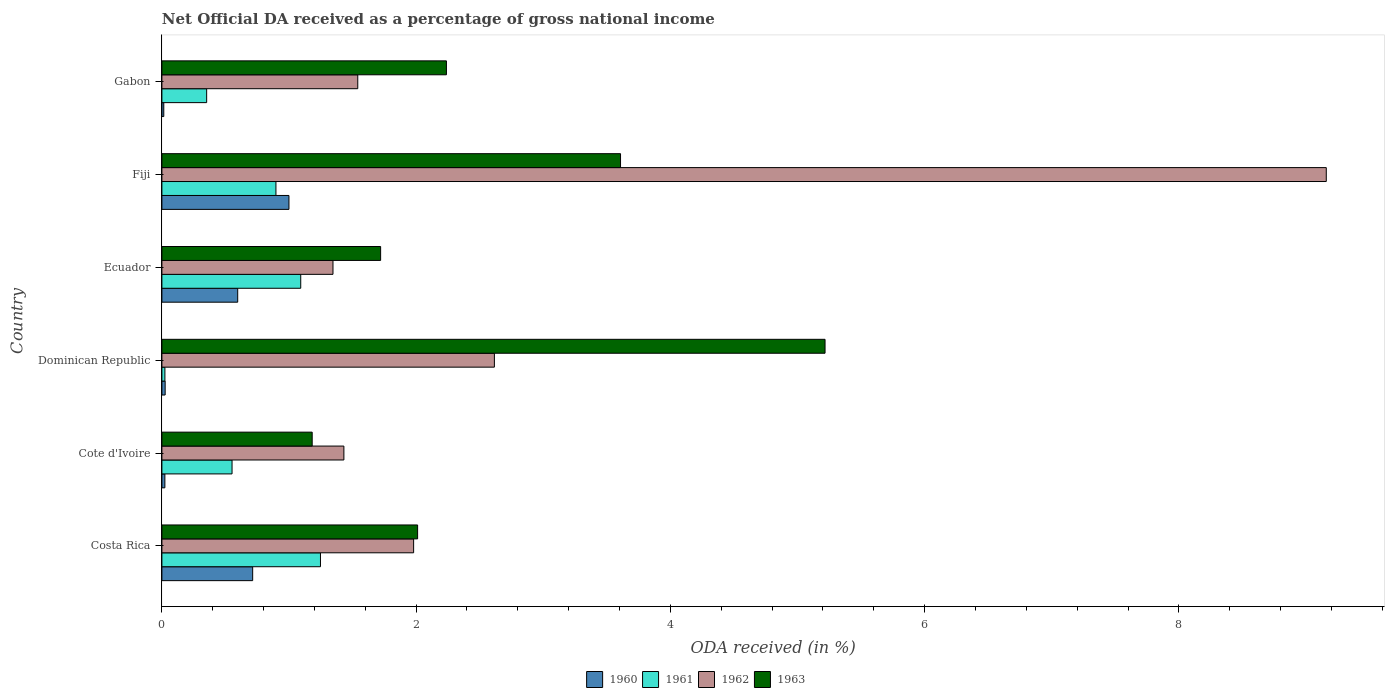How many different coloured bars are there?
Provide a succinct answer. 4. How many bars are there on the 4th tick from the top?
Make the answer very short. 4. How many bars are there on the 4th tick from the bottom?
Keep it short and to the point. 4. What is the label of the 4th group of bars from the top?
Make the answer very short. Dominican Republic. In how many cases, is the number of bars for a given country not equal to the number of legend labels?
Provide a short and direct response. 0. What is the net official DA received in 1961 in Cote d'Ivoire?
Keep it short and to the point. 0.55. Across all countries, what is the maximum net official DA received in 1962?
Keep it short and to the point. 9.16. Across all countries, what is the minimum net official DA received in 1961?
Offer a terse response. 0.02. In which country was the net official DA received in 1960 maximum?
Offer a terse response. Fiji. In which country was the net official DA received in 1962 minimum?
Ensure brevity in your answer.  Ecuador. What is the total net official DA received in 1960 in the graph?
Make the answer very short. 2.37. What is the difference between the net official DA received in 1963 in Costa Rica and that in Dominican Republic?
Your answer should be compact. -3.21. What is the difference between the net official DA received in 1962 in Fiji and the net official DA received in 1963 in Gabon?
Offer a very short reply. 6.92. What is the average net official DA received in 1962 per country?
Ensure brevity in your answer.  3.01. What is the difference between the net official DA received in 1960 and net official DA received in 1963 in Ecuador?
Provide a short and direct response. -1.12. What is the ratio of the net official DA received in 1960 in Cote d'Ivoire to that in Ecuador?
Your answer should be compact. 0.04. What is the difference between the highest and the second highest net official DA received in 1960?
Offer a terse response. 0.29. What is the difference between the highest and the lowest net official DA received in 1961?
Offer a very short reply. 1.22. Is it the case that in every country, the sum of the net official DA received in 1963 and net official DA received in 1960 is greater than the sum of net official DA received in 1961 and net official DA received in 1962?
Provide a short and direct response. No. How many bars are there?
Your answer should be compact. 24. How many countries are there in the graph?
Your answer should be very brief. 6. What is the difference between two consecutive major ticks on the X-axis?
Provide a short and direct response. 2. Are the values on the major ticks of X-axis written in scientific E-notation?
Your answer should be very brief. No. Does the graph contain any zero values?
Give a very brief answer. No. How many legend labels are there?
Provide a succinct answer. 4. What is the title of the graph?
Give a very brief answer. Net Official DA received as a percentage of gross national income. Does "1981" appear as one of the legend labels in the graph?
Provide a succinct answer. No. What is the label or title of the X-axis?
Offer a very short reply. ODA received (in %). What is the label or title of the Y-axis?
Your answer should be very brief. Country. What is the ODA received (in %) of 1960 in Costa Rica?
Your response must be concise. 0.71. What is the ODA received (in %) in 1961 in Costa Rica?
Your response must be concise. 1.25. What is the ODA received (in %) of 1962 in Costa Rica?
Your answer should be compact. 1.98. What is the ODA received (in %) of 1963 in Costa Rica?
Offer a terse response. 2.01. What is the ODA received (in %) in 1960 in Cote d'Ivoire?
Your answer should be compact. 0.02. What is the ODA received (in %) of 1961 in Cote d'Ivoire?
Offer a terse response. 0.55. What is the ODA received (in %) in 1962 in Cote d'Ivoire?
Give a very brief answer. 1.43. What is the ODA received (in %) of 1963 in Cote d'Ivoire?
Your answer should be very brief. 1.18. What is the ODA received (in %) in 1960 in Dominican Republic?
Offer a very short reply. 0.03. What is the ODA received (in %) in 1961 in Dominican Republic?
Your response must be concise. 0.02. What is the ODA received (in %) of 1962 in Dominican Republic?
Give a very brief answer. 2.62. What is the ODA received (in %) in 1963 in Dominican Republic?
Make the answer very short. 5.22. What is the ODA received (in %) of 1960 in Ecuador?
Provide a short and direct response. 0.6. What is the ODA received (in %) of 1961 in Ecuador?
Keep it short and to the point. 1.09. What is the ODA received (in %) in 1962 in Ecuador?
Your response must be concise. 1.35. What is the ODA received (in %) of 1963 in Ecuador?
Your answer should be very brief. 1.72. What is the ODA received (in %) of 1960 in Fiji?
Offer a terse response. 1. What is the ODA received (in %) of 1961 in Fiji?
Provide a succinct answer. 0.9. What is the ODA received (in %) of 1962 in Fiji?
Your answer should be very brief. 9.16. What is the ODA received (in %) of 1963 in Fiji?
Your response must be concise. 3.61. What is the ODA received (in %) of 1960 in Gabon?
Offer a terse response. 0.01. What is the ODA received (in %) of 1961 in Gabon?
Your answer should be compact. 0.35. What is the ODA received (in %) in 1962 in Gabon?
Offer a terse response. 1.54. What is the ODA received (in %) of 1963 in Gabon?
Offer a terse response. 2.24. Across all countries, what is the maximum ODA received (in %) of 1960?
Your answer should be compact. 1. Across all countries, what is the maximum ODA received (in %) of 1961?
Ensure brevity in your answer.  1.25. Across all countries, what is the maximum ODA received (in %) in 1962?
Provide a short and direct response. 9.16. Across all countries, what is the maximum ODA received (in %) in 1963?
Provide a succinct answer. 5.22. Across all countries, what is the minimum ODA received (in %) of 1960?
Keep it short and to the point. 0.01. Across all countries, what is the minimum ODA received (in %) of 1961?
Provide a succinct answer. 0.02. Across all countries, what is the minimum ODA received (in %) of 1962?
Provide a short and direct response. 1.35. Across all countries, what is the minimum ODA received (in %) in 1963?
Your answer should be compact. 1.18. What is the total ODA received (in %) in 1960 in the graph?
Offer a terse response. 2.37. What is the total ODA received (in %) of 1961 in the graph?
Keep it short and to the point. 4.16. What is the total ODA received (in %) in 1962 in the graph?
Offer a terse response. 18.07. What is the total ODA received (in %) of 1963 in the graph?
Provide a succinct answer. 15.98. What is the difference between the ODA received (in %) in 1960 in Costa Rica and that in Cote d'Ivoire?
Your answer should be compact. 0.69. What is the difference between the ODA received (in %) of 1961 in Costa Rica and that in Cote d'Ivoire?
Provide a succinct answer. 0.7. What is the difference between the ODA received (in %) in 1962 in Costa Rica and that in Cote d'Ivoire?
Ensure brevity in your answer.  0.55. What is the difference between the ODA received (in %) of 1963 in Costa Rica and that in Cote d'Ivoire?
Your answer should be compact. 0.83. What is the difference between the ODA received (in %) of 1960 in Costa Rica and that in Dominican Republic?
Ensure brevity in your answer.  0.69. What is the difference between the ODA received (in %) of 1961 in Costa Rica and that in Dominican Republic?
Your answer should be compact. 1.22. What is the difference between the ODA received (in %) in 1962 in Costa Rica and that in Dominican Republic?
Give a very brief answer. -0.64. What is the difference between the ODA received (in %) of 1963 in Costa Rica and that in Dominican Republic?
Give a very brief answer. -3.21. What is the difference between the ODA received (in %) in 1960 in Costa Rica and that in Ecuador?
Keep it short and to the point. 0.12. What is the difference between the ODA received (in %) of 1961 in Costa Rica and that in Ecuador?
Keep it short and to the point. 0.16. What is the difference between the ODA received (in %) of 1962 in Costa Rica and that in Ecuador?
Provide a short and direct response. 0.63. What is the difference between the ODA received (in %) in 1963 in Costa Rica and that in Ecuador?
Your answer should be compact. 0.29. What is the difference between the ODA received (in %) of 1960 in Costa Rica and that in Fiji?
Your response must be concise. -0.29. What is the difference between the ODA received (in %) in 1961 in Costa Rica and that in Fiji?
Keep it short and to the point. 0.35. What is the difference between the ODA received (in %) in 1962 in Costa Rica and that in Fiji?
Your answer should be compact. -7.18. What is the difference between the ODA received (in %) of 1963 in Costa Rica and that in Fiji?
Offer a very short reply. -1.6. What is the difference between the ODA received (in %) in 1960 in Costa Rica and that in Gabon?
Offer a terse response. 0.7. What is the difference between the ODA received (in %) in 1961 in Costa Rica and that in Gabon?
Provide a short and direct response. 0.9. What is the difference between the ODA received (in %) of 1962 in Costa Rica and that in Gabon?
Ensure brevity in your answer.  0.44. What is the difference between the ODA received (in %) in 1963 in Costa Rica and that in Gabon?
Offer a very short reply. -0.23. What is the difference between the ODA received (in %) of 1960 in Cote d'Ivoire and that in Dominican Republic?
Give a very brief answer. -0. What is the difference between the ODA received (in %) of 1961 in Cote d'Ivoire and that in Dominican Republic?
Give a very brief answer. 0.53. What is the difference between the ODA received (in %) in 1962 in Cote d'Ivoire and that in Dominican Republic?
Make the answer very short. -1.18. What is the difference between the ODA received (in %) in 1963 in Cote d'Ivoire and that in Dominican Republic?
Make the answer very short. -4.03. What is the difference between the ODA received (in %) of 1960 in Cote d'Ivoire and that in Ecuador?
Offer a very short reply. -0.57. What is the difference between the ODA received (in %) of 1961 in Cote d'Ivoire and that in Ecuador?
Your answer should be very brief. -0.54. What is the difference between the ODA received (in %) in 1962 in Cote d'Ivoire and that in Ecuador?
Your response must be concise. 0.09. What is the difference between the ODA received (in %) of 1963 in Cote d'Ivoire and that in Ecuador?
Ensure brevity in your answer.  -0.54. What is the difference between the ODA received (in %) in 1960 in Cote d'Ivoire and that in Fiji?
Offer a terse response. -0.98. What is the difference between the ODA received (in %) of 1961 in Cote d'Ivoire and that in Fiji?
Ensure brevity in your answer.  -0.35. What is the difference between the ODA received (in %) in 1962 in Cote d'Ivoire and that in Fiji?
Offer a very short reply. -7.73. What is the difference between the ODA received (in %) in 1963 in Cote d'Ivoire and that in Fiji?
Offer a very short reply. -2.43. What is the difference between the ODA received (in %) in 1960 in Cote d'Ivoire and that in Gabon?
Offer a very short reply. 0.01. What is the difference between the ODA received (in %) of 1961 in Cote d'Ivoire and that in Gabon?
Provide a short and direct response. 0.2. What is the difference between the ODA received (in %) in 1962 in Cote d'Ivoire and that in Gabon?
Provide a short and direct response. -0.11. What is the difference between the ODA received (in %) in 1963 in Cote d'Ivoire and that in Gabon?
Ensure brevity in your answer.  -1.06. What is the difference between the ODA received (in %) in 1960 in Dominican Republic and that in Ecuador?
Your response must be concise. -0.57. What is the difference between the ODA received (in %) in 1961 in Dominican Republic and that in Ecuador?
Ensure brevity in your answer.  -1.07. What is the difference between the ODA received (in %) in 1962 in Dominican Republic and that in Ecuador?
Offer a very short reply. 1.27. What is the difference between the ODA received (in %) in 1963 in Dominican Republic and that in Ecuador?
Provide a short and direct response. 3.5. What is the difference between the ODA received (in %) in 1960 in Dominican Republic and that in Fiji?
Provide a succinct answer. -0.97. What is the difference between the ODA received (in %) in 1961 in Dominican Republic and that in Fiji?
Give a very brief answer. -0.87. What is the difference between the ODA received (in %) in 1962 in Dominican Republic and that in Fiji?
Your answer should be compact. -6.54. What is the difference between the ODA received (in %) in 1963 in Dominican Republic and that in Fiji?
Your answer should be compact. 1.61. What is the difference between the ODA received (in %) in 1960 in Dominican Republic and that in Gabon?
Provide a succinct answer. 0.01. What is the difference between the ODA received (in %) of 1961 in Dominican Republic and that in Gabon?
Offer a terse response. -0.33. What is the difference between the ODA received (in %) in 1962 in Dominican Republic and that in Gabon?
Your answer should be compact. 1.07. What is the difference between the ODA received (in %) in 1963 in Dominican Republic and that in Gabon?
Provide a succinct answer. 2.98. What is the difference between the ODA received (in %) of 1960 in Ecuador and that in Fiji?
Offer a very short reply. -0.4. What is the difference between the ODA received (in %) of 1961 in Ecuador and that in Fiji?
Make the answer very short. 0.2. What is the difference between the ODA received (in %) of 1962 in Ecuador and that in Fiji?
Keep it short and to the point. -7.81. What is the difference between the ODA received (in %) of 1963 in Ecuador and that in Fiji?
Provide a short and direct response. -1.89. What is the difference between the ODA received (in %) of 1960 in Ecuador and that in Gabon?
Offer a very short reply. 0.58. What is the difference between the ODA received (in %) in 1961 in Ecuador and that in Gabon?
Keep it short and to the point. 0.74. What is the difference between the ODA received (in %) of 1962 in Ecuador and that in Gabon?
Your answer should be very brief. -0.2. What is the difference between the ODA received (in %) of 1963 in Ecuador and that in Gabon?
Your answer should be very brief. -0.52. What is the difference between the ODA received (in %) in 1960 in Fiji and that in Gabon?
Your answer should be very brief. 0.98. What is the difference between the ODA received (in %) of 1961 in Fiji and that in Gabon?
Offer a terse response. 0.55. What is the difference between the ODA received (in %) in 1962 in Fiji and that in Gabon?
Your answer should be compact. 7.62. What is the difference between the ODA received (in %) of 1963 in Fiji and that in Gabon?
Offer a very short reply. 1.37. What is the difference between the ODA received (in %) of 1960 in Costa Rica and the ODA received (in %) of 1961 in Cote d'Ivoire?
Offer a very short reply. 0.16. What is the difference between the ODA received (in %) in 1960 in Costa Rica and the ODA received (in %) in 1962 in Cote d'Ivoire?
Offer a terse response. -0.72. What is the difference between the ODA received (in %) of 1960 in Costa Rica and the ODA received (in %) of 1963 in Cote d'Ivoire?
Give a very brief answer. -0.47. What is the difference between the ODA received (in %) of 1961 in Costa Rica and the ODA received (in %) of 1962 in Cote d'Ivoire?
Your answer should be compact. -0.18. What is the difference between the ODA received (in %) in 1961 in Costa Rica and the ODA received (in %) in 1963 in Cote d'Ivoire?
Your answer should be compact. 0.07. What is the difference between the ODA received (in %) in 1962 in Costa Rica and the ODA received (in %) in 1963 in Cote d'Ivoire?
Offer a very short reply. 0.8. What is the difference between the ODA received (in %) in 1960 in Costa Rica and the ODA received (in %) in 1961 in Dominican Republic?
Ensure brevity in your answer.  0.69. What is the difference between the ODA received (in %) in 1960 in Costa Rica and the ODA received (in %) in 1962 in Dominican Republic?
Your answer should be very brief. -1.9. What is the difference between the ODA received (in %) of 1960 in Costa Rica and the ODA received (in %) of 1963 in Dominican Republic?
Provide a succinct answer. -4.5. What is the difference between the ODA received (in %) of 1961 in Costa Rica and the ODA received (in %) of 1962 in Dominican Republic?
Your response must be concise. -1.37. What is the difference between the ODA received (in %) in 1961 in Costa Rica and the ODA received (in %) in 1963 in Dominican Republic?
Your answer should be compact. -3.97. What is the difference between the ODA received (in %) in 1962 in Costa Rica and the ODA received (in %) in 1963 in Dominican Republic?
Your response must be concise. -3.24. What is the difference between the ODA received (in %) in 1960 in Costa Rica and the ODA received (in %) in 1961 in Ecuador?
Give a very brief answer. -0.38. What is the difference between the ODA received (in %) of 1960 in Costa Rica and the ODA received (in %) of 1962 in Ecuador?
Offer a very short reply. -0.63. What is the difference between the ODA received (in %) in 1960 in Costa Rica and the ODA received (in %) in 1963 in Ecuador?
Your response must be concise. -1.01. What is the difference between the ODA received (in %) of 1961 in Costa Rica and the ODA received (in %) of 1962 in Ecuador?
Give a very brief answer. -0.1. What is the difference between the ODA received (in %) in 1961 in Costa Rica and the ODA received (in %) in 1963 in Ecuador?
Your answer should be compact. -0.47. What is the difference between the ODA received (in %) of 1962 in Costa Rica and the ODA received (in %) of 1963 in Ecuador?
Provide a succinct answer. 0.26. What is the difference between the ODA received (in %) in 1960 in Costa Rica and the ODA received (in %) in 1961 in Fiji?
Provide a short and direct response. -0.18. What is the difference between the ODA received (in %) in 1960 in Costa Rica and the ODA received (in %) in 1962 in Fiji?
Your response must be concise. -8.45. What is the difference between the ODA received (in %) in 1960 in Costa Rica and the ODA received (in %) in 1963 in Fiji?
Make the answer very short. -2.89. What is the difference between the ODA received (in %) in 1961 in Costa Rica and the ODA received (in %) in 1962 in Fiji?
Provide a succinct answer. -7.91. What is the difference between the ODA received (in %) of 1961 in Costa Rica and the ODA received (in %) of 1963 in Fiji?
Keep it short and to the point. -2.36. What is the difference between the ODA received (in %) of 1962 in Costa Rica and the ODA received (in %) of 1963 in Fiji?
Offer a very short reply. -1.63. What is the difference between the ODA received (in %) in 1960 in Costa Rica and the ODA received (in %) in 1961 in Gabon?
Ensure brevity in your answer.  0.36. What is the difference between the ODA received (in %) of 1960 in Costa Rica and the ODA received (in %) of 1962 in Gabon?
Ensure brevity in your answer.  -0.83. What is the difference between the ODA received (in %) of 1960 in Costa Rica and the ODA received (in %) of 1963 in Gabon?
Provide a succinct answer. -1.52. What is the difference between the ODA received (in %) of 1961 in Costa Rica and the ODA received (in %) of 1962 in Gabon?
Keep it short and to the point. -0.29. What is the difference between the ODA received (in %) of 1961 in Costa Rica and the ODA received (in %) of 1963 in Gabon?
Provide a short and direct response. -0.99. What is the difference between the ODA received (in %) of 1962 in Costa Rica and the ODA received (in %) of 1963 in Gabon?
Your answer should be compact. -0.26. What is the difference between the ODA received (in %) in 1960 in Cote d'Ivoire and the ODA received (in %) in 1961 in Dominican Republic?
Your response must be concise. -0. What is the difference between the ODA received (in %) in 1960 in Cote d'Ivoire and the ODA received (in %) in 1962 in Dominican Republic?
Offer a terse response. -2.59. What is the difference between the ODA received (in %) of 1960 in Cote d'Ivoire and the ODA received (in %) of 1963 in Dominican Republic?
Offer a terse response. -5.19. What is the difference between the ODA received (in %) of 1961 in Cote d'Ivoire and the ODA received (in %) of 1962 in Dominican Republic?
Your response must be concise. -2.06. What is the difference between the ODA received (in %) of 1961 in Cote d'Ivoire and the ODA received (in %) of 1963 in Dominican Republic?
Ensure brevity in your answer.  -4.67. What is the difference between the ODA received (in %) of 1962 in Cote d'Ivoire and the ODA received (in %) of 1963 in Dominican Republic?
Provide a succinct answer. -3.79. What is the difference between the ODA received (in %) of 1960 in Cote d'Ivoire and the ODA received (in %) of 1961 in Ecuador?
Your answer should be very brief. -1.07. What is the difference between the ODA received (in %) of 1960 in Cote d'Ivoire and the ODA received (in %) of 1962 in Ecuador?
Provide a short and direct response. -1.32. What is the difference between the ODA received (in %) in 1960 in Cote d'Ivoire and the ODA received (in %) in 1963 in Ecuador?
Your answer should be very brief. -1.7. What is the difference between the ODA received (in %) of 1961 in Cote d'Ivoire and the ODA received (in %) of 1962 in Ecuador?
Offer a terse response. -0.79. What is the difference between the ODA received (in %) of 1961 in Cote d'Ivoire and the ODA received (in %) of 1963 in Ecuador?
Your answer should be compact. -1.17. What is the difference between the ODA received (in %) of 1962 in Cote d'Ivoire and the ODA received (in %) of 1963 in Ecuador?
Your response must be concise. -0.29. What is the difference between the ODA received (in %) in 1960 in Cote d'Ivoire and the ODA received (in %) in 1961 in Fiji?
Give a very brief answer. -0.87. What is the difference between the ODA received (in %) in 1960 in Cote d'Ivoire and the ODA received (in %) in 1962 in Fiji?
Your response must be concise. -9.14. What is the difference between the ODA received (in %) of 1960 in Cote d'Ivoire and the ODA received (in %) of 1963 in Fiji?
Your answer should be very brief. -3.58. What is the difference between the ODA received (in %) in 1961 in Cote d'Ivoire and the ODA received (in %) in 1962 in Fiji?
Provide a short and direct response. -8.61. What is the difference between the ODA received (in %) of 1961 in Cote d'Ivoire and the ODA received (in %) of 1963 in Fiji?
Provide a succinct answer. -3.06. What is the difference between the ODA received (in %) of 1962 in Cote d'Ivoire and the ODA received (in %) of 1963 in Fiji?
Your answer should be very brief. -2.18. What is the difference between the ODA received (in %) of 1960 in Cote d'Ivoire and the ODA received (in %) of 1961 in Gabon?
Keep it short and to the point. -0.33. What is the difference between the ODA received (in %) in 1960 in Cote d'Ivoire and the ODA received (in %) in 1962 in Gabon?
Provide a succinct answer. -1.52. What is the difference between the ODA received (in %) of 1960 in Cote d'Ivoire and the ODA received (in %) of 1963 in Gabon?
Make the answer very short. -2.21. What is the difference between the ODA received (in %) of 1961 in Cote d'Ivoire and the ODA received (in %) of 1962 in Gabon?
Make the answer very short. -0.99. What is the difference between the ODA received (in %) of 1961 in Cote d'Ivoire and the ODA received (in %) of 1963 in Gabon?
Your answer should be very brief. -1.69. What is the difference between the ODA received (in %) of 1962 in Cote d'Ivoire and the ODA received (in %) of 1963 in Gabon?
Provide a succinct answer. -0.81. What is the difference between the ODA received (in %) in 1960 in Dominican Republic and the ODA received (in %) in 1961 in Ecuador?
Offer a terse response. -1.07. What is the difference between the ODA received (in %) in 1960 in Dominican Republic and the ODA received (in %) in 1962 in Ecuador?
Make the answer very short. -1.32. What is the difference between the ODA received (in %) of 1960 in Dominican Republic and the ODA received (in %) of 1963 in Ecuador?
Offer a very short reply. -1.69. What is the difference between the ODA received (in %) of 1961 in Dominican Republic and the ODA received (in %) of 1962 in Ecuador?
Keep it short and to the point. -1.32. What is the difference between the ODA received (in %) of 1961 in Dominican Republic and the ODA received (in %) of 1963 in Ecuador?
Provide a short and direct response. -1.7. What is the difference between the ODA received (in %) in 1962 in Dominican Republic and the ODA received (in %) in 1963 in Ecuador?
Provide a succinct answer. 0.9. What is the difference between the ODA received (in %) of 1960 in Dominican Republic and the ODA received (in %) of 1961 in Fiji?
Your answer should be very brief. -0.87. What is the difference between the ODA received (in %) of 1960 in Dominican Republic and the ODA received (in %) of 1962 in Fiji?
Give a very brief answer. -9.13. What is the difference between the ODA received (in %) of 1960 in Dominican Republic and the ODA received (in %) of 1963 in Fiji?
Offer a terse response. -3.58. What is the difference between the ODA received (in %) in 1961 in Dominican Republic and the ODA received (in %) in 1962 in Fiji?
Your answer should be very brief. -9.14. What is the difference between the ODA received (in %) of 1961 in Dominican Republic and the ODA received (in %) of 1963 in Fiji?
Your answer should be very brief. -3.58. What is the difference between the ODA received (in %) of 1962 in Dominican Republic and the ODA received (in %) of 1963 in Fiji?
Your response must be concise. -0.99. What is the difference between the ODA received (in %) in 1960 in Dominican Republic and the ODA received (in %) in 1961 in Gabon?
Your answer should be very brief. -0.33. What is the difference between the ODA received (in %) in 1960 in Dominican Republic and the ODA received (in %) in 1962 in Gabon?
Offer a very short reply. -1.52. What is the difference between the ODA received (in %) of 1960 in Dominican Republic and the ODA received (in %) of 1963 in Gabon?
Provide a succinct answer. -2.21. What is the difference between the ODA received (in %) of 1961 in Dominican Republic and the ODA received (in %) of 1962 in Gabon?
Offer a very short reply. -1.52. What is the difference between the ODA received (in %) in 1961 in Dominican Republic and the ODA received (in %) in 1963 in Gabon?
Your answer should be compact. -2.21. What is the difference between the ODA received (in %) of 1962 in Dominican Republic and the ODA received (in %) of 1963 in Gabon?
Provide a short and direct response. 0.38. What is the difference between the ODA received (in %) of 1960 in Ecuador and the ODA received (in %) of 1961 in Fiji?
Offer a very short reply. -0.3. What is the difference between the ODA received (in %) of 1960 in Ecuador and the ODA received (in %) of 1962 in Fiji?
Provide a short and direct response. -8.56. What is the difference between the ODA received (in %) of 1960 in Ecuador and the ODA received (in %) of 1963 in Fiji?
Offer a terse response. -3.01. What is the difference between the ODA received (in %) in 1961 in Ecuador and the ODA received (in %) in 1962 in Fiji?
Offer a very short reply. -8.07. What is the difference between the ODA received (in %) in 1961 in Ecuador and the ODA received (in %) in 1963 in Fiji?
Give a very brief answer. -2.52. What is the difference between the ODA received (in %) of 1962 in Ecuador and the ODA received (in %) of 1963 in Fiji?
Give a very brief answer. -2.26. What is the difference between the ODA received (in %) in 1960 in Ecuador and the ODA received (in %) in 1961 in Gabon?
Ensure brevity in your answer.  0.24. What is the difference between the ODA received (in %) in 1960 in Ecuador and the ODA received (in %) in 1962 in Gabon?
Provide a succinct answer. -0.94. What is the difference between the ODA received (in %) of 1960 in Ecuador and the ODA received (in %) of 1963 in Gabon?
Your answer should be very brief. -1.64. What is the difference between the ODA received (in %) in 1961 in Ecuador and the ODA received (in %) in 1962 in Gabon?
Keep it short and to the point. -0.45. What is the difference between the ODA received (in %) of 1961 in Ecuador and the ODA received (in %) of 1963 in Gabon?
Offer a terse response. -1.15. What is the difference between the ODA received (in %) of 1962 in Ecuador and the ODA received (in %) of 1963 in Gabon?
Provide a succinct answer. -0.89. What is the difference between the ODA received (in %) in 1960 in Fiji and the ODA received (in %) in 1961 in Gabon?
Provide a succinct answer. 0.65. What is the difference between the ODA received (in %) in 1960 in Fiji and the ODA received (in %) in 1962 in Gabon?
Your answer should be very brief. -0.54. What is the difference between the ODA received (in %) of 1960 in Fiji and the ODA received (in %) of 1963 in Gabon?
Ensure brevity in your answer.  -1.24. What is the difference between the ODA received (in %) of 1961 in Fiji and the ODA received (in %) of 1962 in Gabon?
Provide a short and direct response. -0.64. What is the difference between the ODA received (in %) of 1961 in Fiji and the ODA received (in %) of 1963 in Gabon?
Keep it short and to the point. -1.34. What is the difference between the ODA received (in %) in 1962 in Fiji and the ODA received (in %) in 1963 in Gabon?
Provide a succinct answer. 6.92. What is the average ODA received (in %) in 1960 per country?
Provide a short and direct response. 0.4. What is the average ODA received (in %) of 1961 per country?
Provide a short and direct response. 0.69. What is the average ODA received (in %) in 1962 per country?
Make the answer very short. 3.01. What is the average ODA received (in %) of 1963 per country?
Make the answer very short. 2.66. What is the difference between the ODA received (in %) of 1960 and ODA received (in %) of 1961 in Costa Rica?
Ensure brevity in your answer.  -0.53. What is the difference between the ODA received (in %) of 1960 and ODA received (in %) of 1962 in Costa Rica?
Make the answer very short. -1.27. What is the difference between the ODA received (in %) in 1960 and ODA received (in %) in 1963 in Costa Rica?
Provide a succinct answer. -1.3. What is the difference between the ODA received (in %) of 1961 and ODA received (in %) of 1962 in Costa Rica?
Give a very brief answer. -0.73. What is the difference between the ODA received (in %) in 1961 and ODA received (in %) in 1963 in Costa Rica?
Give a very brief answer. -0.76. What is the difference between the ODA received (in %) in 1962 and ODA received (in %) in 1963 in Costa Rica?
Your answer should be compact. -0.03. What is the difference between the ODA received (in %) of 1960 and ODA received (in %) of 1961 in Cote d'Ivoire?
Give a very brief answer. -0.53. What is the difference between the ODA received (in %) in 1960 and ODA received (in %) in 1962 in Cote d'Ivoire?
Offer a very short reply. -1.41. What is the difference between the ODA received (in %) of 1960 and ODA received (in %) of 1963 in Cote d'Ivoire?
Provide a short and direct response. -1.16. What is the difference between the ODA received (in %) in 1961 and ODA received (in %) in 1962 in Cote d'Ivoire?
Your response must be concise. -0.88. What is the difference between the ODA received (in %) of 1961 and ODA received (in %) of 1963 in Cote d'Ivoire?
Provide a succinct answer. -0.63. What is the difference between the ODA received (in %) in 1962 and ODA received (in %) in 1963 in Cote d'Ivoire?
Provide a succinct answer. 0.25. What is the difference between the ODA received (in %) of 1960 and ODA received (in %) of 1961 in Dominican Republic?
Make the answer very short. 0. What is the difference between the ODA received (in %) of 1960 and ODA received (in %) of 1962 in Dominican Republic?
Make the answer very short. -2.59. What is the difference between the ODA received (in %) in 1960 and ODA received (in %) in 1963 in Dominican Republic?
Ensure brevity in your answer.  -5.19. What is the difference between the ODA received (in %) in 1961 and ODA received (in %) in 1962 in Dominican Republic?
Offer a very short reply. -2.59. What is the difference between the ODA received (in %) in 1961 and ODA received (in %) in 1963 in Dominican Republic?
Give a very brief answer. -5.19. What is the difference between the ODA received (in %) in 1962 and ODA received (in %) in 1963 in Dominican Republic?
Your answer should be very brief. -2.6. What is the difference between the ODA received (in %) of 1960 and ODA received (in %) of 1961 in Ecuador?
Your answer should be very brief. -0.5. What is the difference between the ODA received (in %) in 1960 and ODA received (in %) in 1962 in Ecuador?
Give a very brief answer. -0.75. What is the difference between the ODA received (in %) in 1960 and ODA received (in %) in 1963 in Ecuador?
Ensure brevity in your answer.  -1.12. What is the difference between the ODA received (in %) in 1961 and ODA received (in %) in 1962 in Ecuador?
Give a very brief answer. -0.25. What is the difference between the ODA received (in %) of 1961 and ODA received (in %) of 1963 in Ecuador?
Provide a succinct answer. -0.63. What is the difference between the ODA received (in %) of 1962 and ODA received (in %) of 1963 in Ecuador?
Your answer should be compact. -0.37. What is the difference between the ODA received (in %) of 1960 and ODA received (in %) of 1961 in Fiji?
Ensure brevity in your answer.  0.1. What is the difference between the ODA received (in %) of 1960 and ODA received (in %) of 1962 in Fiji?
Provide a short and direct response. -8.16. What is the difference between the ODA received (in %) of 1960 and ODA received (in %) of 1963 in Fiji?
Give a very brief answer. -2.61. What is the difference between the ODA received (in %) of 1961 and ODA received (in %) of 1962 in Fiji?
Make the answer very short. -8.26. What is the difference between the ODA received (in %) in 1961 and ODA received (in %) in 1963 in Fiji?
Keep it short and to the point. -2.71. What is the difference between the ODA received (in %) of 1962 and ODA received (in %) of 1963 in Fiji?
Provide a short and direct response. 5.55. What is the difference between the ODA received (in %) in 1960 and ODA received (in %) in 1961 in Gabon?
Provide a short and direct response. -0.34. What is the difference between the ODA received (in %) of 1960 and ODA received (in %) of 1962 in Gabon?
Keep it short and to the point. -1.53. What is the difference between the ODA received (in %) of 1960 and ODA received (in %) of 1963 in Gabon?
Offer a terse response. -2.22. What is the difference between the ODA received (in %) of 1961 and ODA received (in %) of 1962 in Gabon?
Provide a succinct answer. -1.19. What is the difference between the ODA received (in %) of 1961 and ODA received (in %) of 1963 in Gabon?
Offer a terse response. -1.89. What is the difference between the ODA received (in %) of 1962 and ODA received (in %) of 1963 in Gabon?
Give a very brief answer. -0.7. What is the ratio of the ODA received (in %) in 1960 in Costa Rica to that in Cote d'Ivoire?
Provide a succinct answer. 30.57. What is the ratio of the ODA received (in %) of 1961 in Costa Rica to that in Cote d'Ivoire?
Offer a terse response. 2.26. What is the ratio of the ODA received (in %) in 1962 in Costa Rica to that in Cote d'Ivoire?
Your response must be concise. 1.38. What is the ratio of the ODA received (in %) in 1963 in Costa Rica to that in Cote d'Ivoire?
Provide a succinct answer. 1.7. What is the ratio of the ODA received (in %) in 1960 in Costa Rica to that in Dominican Republic?
Provide a succinct answer. 27.82. What is the ratio of the ODA received (in %) in 1961 in Costa Rica to that in Dominican Republic?
Keep it short and to the point. 52.85. What is the ratio of the ODA received (in %) in 1962 in Costa Rica to that in Dominican Republic?
Your response must be concise. 0.76. What is the ratio of the ODA received (in %) in 1963 in Costa Rica to that in Dominican Republic?
Provide a succinct answer. 0.39. What is the ratio of the ODA received (in %) of 1960 in Costa Rica to that in Ecuador?
Give a very brief answer. 1.2. What is the ratio of the ODA received (in %) in 1961 in Costa Rica to that in Ecuador?
Offer a very short reply. 1.14. What is the ratio of the ODA received (in %) in 1962 in Costa Rica to that in Ecuador?
Provide a short and direct response. 1.47. What is the ratio of the ODA received (in %) of 1963 in Costa Rica to that in Ecuador?
Offer a terse response. 1.17. What is the ratio of the ODA received (in %) in 1960 in Costa Rica to that in Fiji?
Keep it short and to the point. 0.71. What is the ratio of the ODA received (in %) of 1961 in Costa Rica to that in Fiji?
Ensure brevity in your answer.  1.39. What is the ratio of the ODA received (in %) in 1962 in Costa Rica to that in Fiji?
Provide a succinct answer. 0.22. What is the ratio of the ODA received (in %) in 1963 in Costa Rica to that in Fiji?
Give a very brief answer. 0.56. What is the ratio of the ODA received (in %) in 1960 in Costa Rica to that in Gabon?
Make the answer very short. 48.13. What is the ratio of the ODA received (in %) of 1961 in Costa Rica to that in Gabon?
Your answer should be compact. 3.54. What is the ratio of the ODA received (in %) of 1962 in Costa Rica to that in Gabon?
Keep it short and to the point. 1.29. What is the ratio of the ODA received (in %) in 1963 in Costa Rica to that in Gabon?
Keep it short and to the point. 0.9. What is the ratio of the ODA received (in %) in 1960 in Cote d'Ivoire to that in Dominican Republic?
Your answer should be compact. 0.91. What is the ratio of the ODA received (in %) of 1961 in Cote d'Ivoire to that in Dominican Republic?
Keep it short and to the point. 23.38. What is the ratio of the ODA received (in %) in 1962 in Cote d'Ivoire to that in Dominican Republic?
Your answer should be very brief. 0.55. What is the ratio of the ODA received (in %) in 1963 in Cote d'Ivoire to that in Dominican Republic?
Provide a succinct answer. 0.23. What is the ratio of the ODA received (in %) of 1960 in Cote d'Ivoire to that in Ecuador?
Offer a very short reply. 0.04. What is the ratio of the ODA received (in %) of 1961 in Cote d'Ivoire to that in Ecuador?
Provide a short and direct response. 0.51. What is the ratio of the ODA received (in %) of 1962 in Cote d'Ivoire to that in Ecuador?
Provide a short and direct response. 1.06. What is the ratio of the ODA received (in %) in 1963 in Cote d'Ivoire to that in Ecuador?
Offer a terse response. 0.69. What is the ratio of the ODA received (in %) in 1960 in Cote d'Ivoire to that in Fiji?
Your response must be concise. 0.02. What is the ratio of the ODA received (in %) of 1961 in Cote d'Ivoire to that in Fiji?
Offer a very short reply. 0.61. What is the ratio of the ODA received (in %) of 1962 in Cote d'Ivoire to that in Fiji?
Provide a short and direct response. 0.16. What is the ratio of the ODA received (in %) of 1963 in Cote d'Ivoire to that in Fiji?
Keep it short and to the point. 0.33. What is the ratio of the ODA received (in %) of 1960 in Cote d'Ivoire to that in Gabon?
Your answer should be very brief. 1.57. What is the ratio of the ODA received (in %) in 1961 in Cote d'Ivoire to that in Gabon?
Provide a succinct answer. 1.57. What is the ratio of the ODA received (in %) of 1962 in Cote d'Ivoire to that in Gabon?
Your answer should be very brief. 0.93. What is the ratio of the ODA received (in %) of 1963 in Cote d'Ivoire to that in Gabon?
Your response must be concise. 0.53. What is the ratio of the ODA received (in %) in 1960 in Dominican Republic to that in Ecuador?
Keep it short and to the point. 0.04. What is the ratio of the ODA received (in %) in 1961 in Dominican Republic to that in Ecuador?
Offer a terse response. 0.02. What is the ratio of the ODA received (in %) in 1962 in Dominican Republic to that in Ecuador?
Offer a terse response. 1.94. What is the ratio of the ODA received (in %) in 1963 in Dominican Republic to that in Ecuador?
Your response must be concise. 3.03. What is the ratio of the ODA received (in %) of 1960 in Dominican Republic to that in Fiji?
Offer a terse response. 0.03. What is the ratio of the ODA received (in %) of 1961 in Dominican Republic to that in Fiji?
Keep it short and to the point. 0.03. What is the ratio of the ODA received (in %) in 1962 in Dominican Republic to that in Fiji?
Ensure brevity in your answer.  0.29. What is the ratio of the ODA received (in %) in 1963 in Dominican Republic to that in Fiji?
Offer a very short reply. 1.45. What is the ratio of the ODA received (in %) of 1960 in Dominican Republic to that in Gabon?
Your answer should be compact. 1.73. What is the ratio of the ODA received (in %) of 1961 in Dominican Republic to that in Gabon?
Keep it short and to the point. 0.07. What is the ratio of the ODA received (in %) in 1962 in Dominican Republic to that in Gabon?
Give a very brief answer. 1.7. What is the ratio of the ODA received (in %) in 1963 in Dominican Republic to that in Gabon?
Provide a short and direct response. 2.33. What is the ratio of the ODA received (in %) of 1960 in Ecuador to that in Fiji?
Your answer should be very brief. 0.6. What is the ratio of the ODA received (in %) of 1961 in Ecuador to that in Fiji?
Make the answer very short. 1.22. What is the ratio of the ODA received (in %) of 1962 in Ecuador to that in Fiji?
Your answer should be compact. 0.15. What is the ratio of the ODA received (in %) of 1963 in Ecuador to that in Fiji?
Your answer should be compact. 0.48. What is the ratio of the ODA received (in %) in 1960 in Ecuador to that in Gabon?
Provide a succinct answer. 40.19. What is the ratio of the ODA received (in %) in 1961 in Ecuador to that in Gabon?
Provide a succinct answer. 3.1. What is the ratio of the ODA received (in %) in 1962 in Ecuador to that in Gabon?
Provide a short and direct response. 0.87. What is the ratio of the ODA received (in %) of 1963 in Ecuador to that in Gabon?
Offer a terse response. 0.77. What is the ratio of the ODA received (in %) in 1960 in Fiji to that in Gabon?
Your answer should be very brief. 67.36. What is the ratio of the ODA received (in %) of 1961 in Fiji to that in Gabon?
Keep it short and to the point. 2.55. What is the ratio of the ODA received (in %) in 1962 in Fiji to that in Gabon?
Provide a short and direct response. 5.94. What is the ratio of the ODA received (in %) of 1963 in Fiji to that in Gabon?
Your response must be concise. 1.61. What is the difference between the highest and the second highest ODA received (in %) of 1960?
Give a very brief answer. 0.29. What is the difference between the highest and the second highest ODA received (in %) of 1961?
Offer a terse response. 0.16. What is the difference between the highest and the second highest ODA received (in %) in 1962?
Offer a terse response. 6.54. What is the difference between the highest and the second highest ODA received (in %) in 1963?
Ensure brevity in your answer.  1.61. What is the difference between the highest and the lowest ODA received (in %) in 1960?
Provide a succinct answer. 0.98. What is the difference between the highest and the lowest ODA received (in %) in 1961?
Your answer should be very brief. 1.22. What is the difference between the highest and the lowest ODA received (in %) of 1962?
Ensure brevity in your answer.  7.81. What is the difference between the highest and the lowest ODA received (in %) in 1963?
Give a very brief answer. 4.03. 